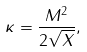Convert formula to latex. <formula><loc_0><loc_0><loc_500><loc_500>\kappa = \frac { M ^ { 2 } } { 2 \sqrt { X } } ,</formula> 